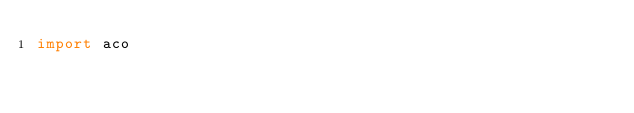Convert code to text. <code><loc_0><loc_0><loc_500><loc_500><_Python_>import aco
</code> 